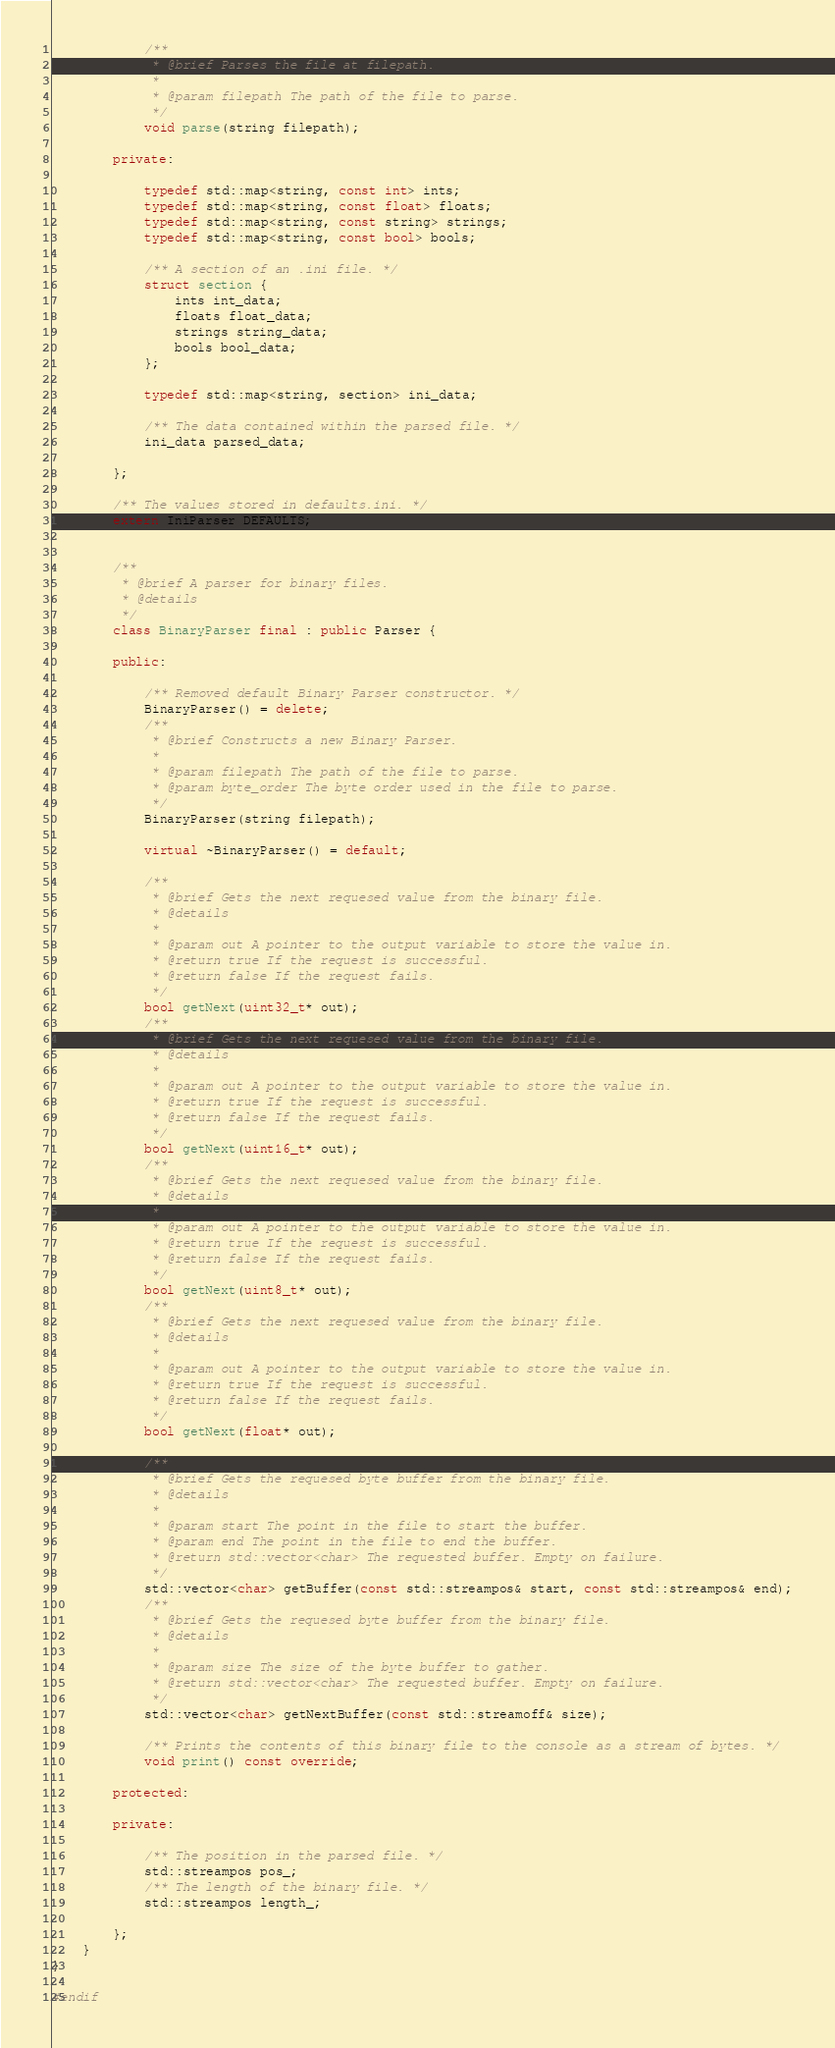Convert code to text. <code><loc_0><loc_0><loc_500><loc_500><_C++_>
            /**
             * @brief Parses the file at filepath.
             * 
             * @param filepath The path of the file to parse.
             */
            void parse(string filepath);

        private:

            typedef std::map<string, const int> ints;
            typedef std::map<string, const float> floats;
            typedef std::map<string, const string> strings;
            typedef std::map<string, const bool> bools;

            /** A section of an .ini file. */
            struct section {
                ints int_data;
                floats float_data;
                strings string_data;
                bools bool_data;
            };

            typedef std::map<string, section> ini_data;

            /** The data contained within the parsed file. */
            ini_data parsed_data;

        };

        /** The values stored in defaults.ini. */
        extern IniParser DEFAULTS;


        /**
         * @brief A parser for binary files.
         * @details
         */
        class BinaryParser final : public Parser {

        public:

            /** Removed default Binary Parser constructor. */
            BinaryParser() = delete;
            /**
             * @brief Constructs a new Binary Parser.
             *
             * @param filepath The path of the file to parse.
             * @param byte_order The byte order used in the file to parse.
             */
            BinaryParser(string filepath);

            virtual ~BinaryParser() = default;

            /**
             * @brief Gets the next requesed value from the binary file.
             * @details
             *
             * @param out A pointer to the output variable to store the value in.
             * @return true If the request is successful.
             * @return false If the request fails.
             */
            bool getNext(uint32_t* out);
            /**
             * @brief Gets the next requesed value from the binary file.
             * @details
             *
             * @param out A pointer to the output variable to store the value in.
             * @return true If the request is successful.
             * @return false If the request fails.
             */
            bool getNext(uint16_t* out);
            /**
             * @brief Gets the next requesed value from the binary file.
             * @details
             *
             * @param out A pointer to the output variable to store the value in.
             * @return true If the request is successful.
             * @return false If the request fails.
             */
            bool getNext(uint8_t* out);
            /**
             * @brief Gets the next requesed value from the binary file.
             * @details
             *
             * @param out A pointer to the output variable to store the value in.
             * @return true If the request is successful.
             * @return false If the request fails.
             */
            bool getNext(float* out);

            /**
             * @brief Gets the requesed byte buffer from the binary file.
             * @details
             *
             * @param start The point in the file to start the buffer.
             * @param end The point in the file to end the buffer.
             * @return std::vector<char> The requested buffer. Empty on failure.
             */
            std::vector<char> getBuffer(const std::streampos& start, const std::streampos& end);
            /**
             * @brief Gets the requesed byte buffer from the binary file.
             * @details
             *
             * @param size The size of the byte buffer to gather.
             * @return std::vector<char> The requested buffer. Empty on failure.
             */
            std::vector<char> getNextBuffer(const std::streamoff& size);

            /** Prints the contents of this binary file to the console as a stream of bytes. */
            void print() const override;

        protected:

        private:

            /** The position in the parsed file. */
            std::streampos pos_;
            /** The length of the binary file. */
            std::streampos length_;

        };
    }
}

#endif</code> 